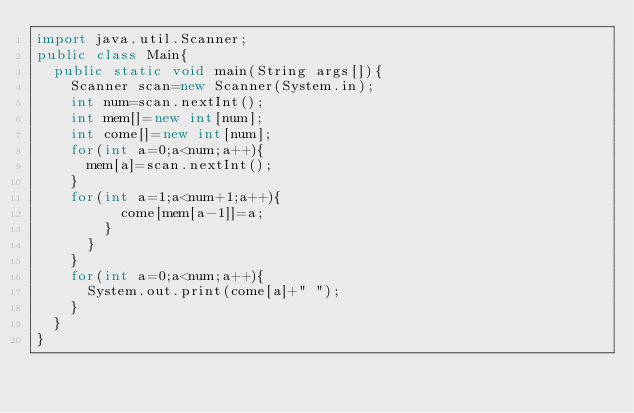Convert code to text. <code><loc_0><loc_0><loc_500><loc_500><_Java_>import java.util.Scanner;
public class Main{
  public static void main(String args[]){
    Scanner scan=new Scanner(System.in);
    int num=scan.nextInt();
    int mem[]=new int[num];
    int come[]=new int[num];
    for(int a=0;a<num;a++){
      mem[a]=scan.nextInt();
    }
    for(int a=1;a<num+1;a++){
          come[mem[a-1]]=a;
        }
      }
    }
    for(int a=0;a<num;a++){
      System.out.print(come[a]+" ");
    }
  }
}</code> 